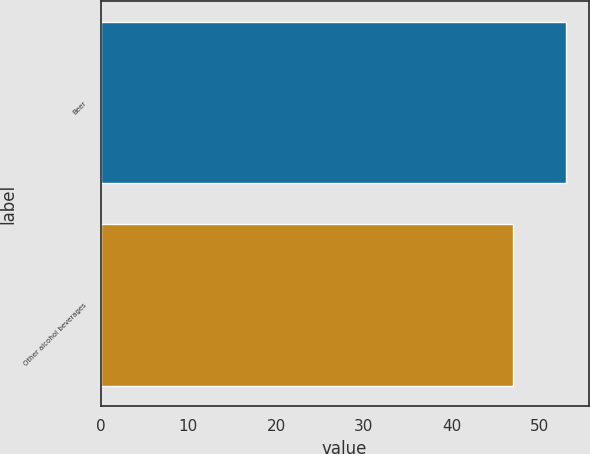Convert chart. <chart><loc_0><loc_0><loc_500><loc_500><bar_chart><fcel>Beer<fcel>Other alcohol beverages<nl><fcel>53<fcel>47<nl></chart> 